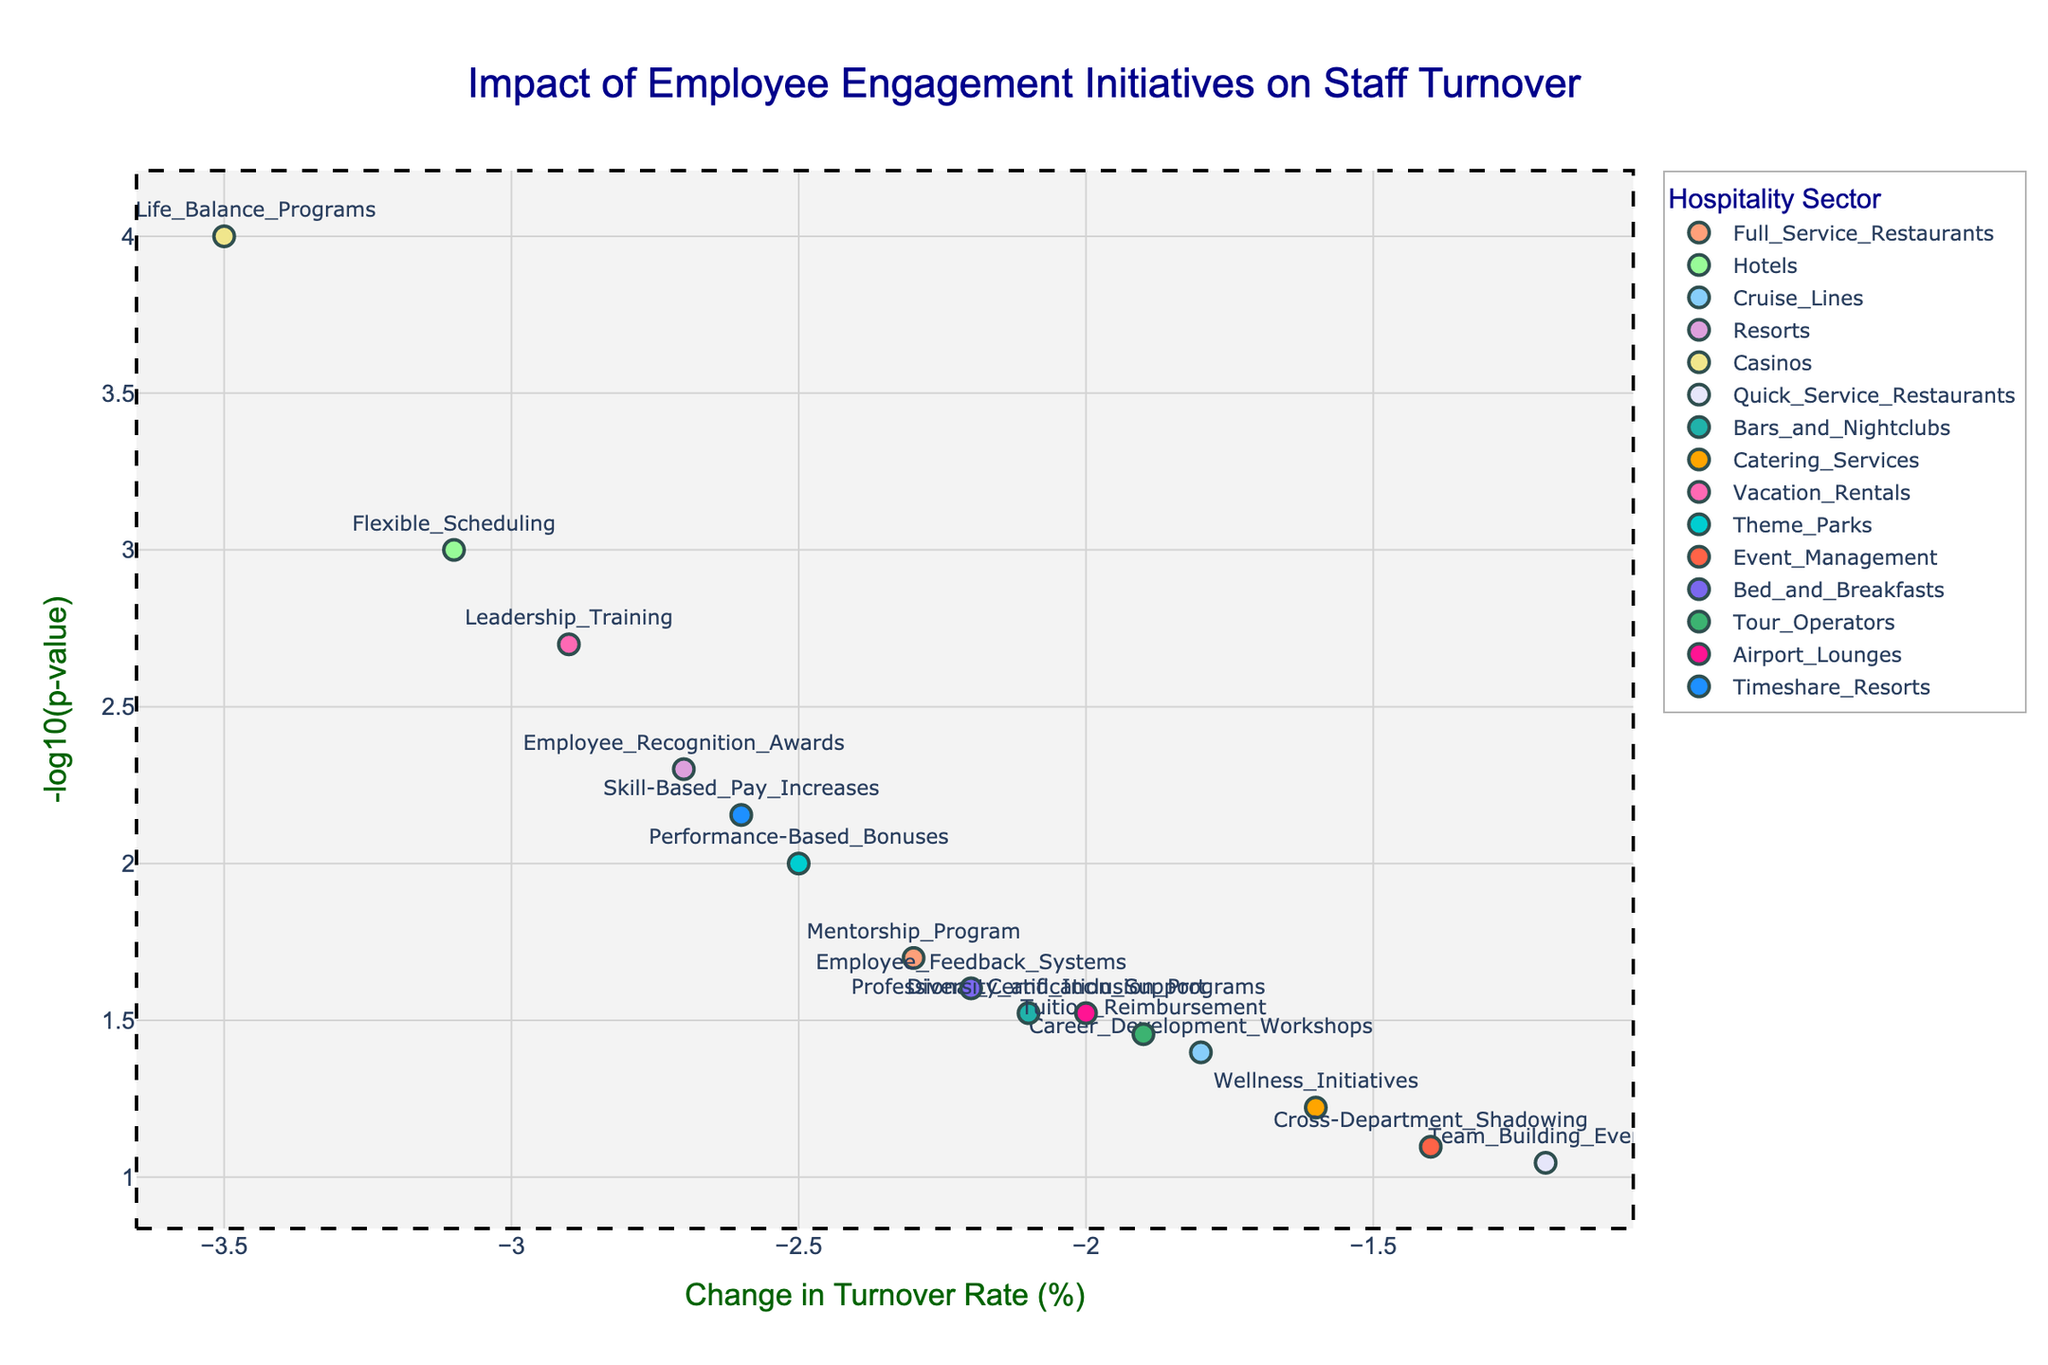How many unique hospitality sectors are represented in the plot? Identify the legend which lists all unique sectors. There are 15 different sectors mentioned: Full-Service Restaurants, Hotels, Cruise Lines, Resorts, Casinos, Quick-Service Restaurants, Bars and Nightclubs, Catering Services, Vacation Rentals, Theme Parks, Event Management, Bed and Breakfasts, Tour Operators, Airport Lounges, and Timeshare Resorts.
Answer: 15 Which staff initiative shows the largest decrease in turnover rates? Look at the points on the plot and identify the one farthest to the left on the x-axis (most negative turnover change). The initiative with the most negative turnover change is "Work-Life Balance Programs," at -3.5%.
Answer: Work-Life Balance Programs What is the significance threshold line value on the y-axis? Locate the dashed red line on the y-axis, indicating the significance threshold. The y-value where it lies is -log10(0.05), which calculates to 1.3.
Answer: 1.3 Which sector has the highest statistical significance (lowest p-value) for its staff initiative? Identify the point with the highest y-value on the plot, as higher -log10(p) correlates with lower p-value. "Work-Life Balance Programs" in Casinos has the highest y-value, with a very low p-value of 0.0001.
Answer: Casinos How many staff initiatives have a p-value below 0.01? Count the number of points above the y=axial significance threshold line (above 1.3 on the y-axis). Six initiatives cross this threshold.
Answer: 6 Which sector's staff initiative lies closest to the threshold line and what is the initiative? Identify the point closest to the y-value of 1.3. "Employee Feedback Systems” at Bed and Breakfasts is just slightly above this line.
Answer: Bed and Breakfasts, Employee Feedback Systems What is the total change in turnover rates for "Performance-Based Bonuses" and "Mentorship Program"? Sum the turnover changes. "Performance-Based Bonuses" is -2.5% and "Mentorship Program" is -2.3%. Summing these, -2.5 + (-2.3) = -4.8%.
Answer: -4.8% Which sectors have initiatives with a turnover change less than -2.5%? Determine which points lie left of -2.5 on the x-axis. Three sectors meet this criterion: Residences with "Employee Recognition Awards" (-2.7%), Theme Parks with "Performance-Based Bonuses" (-2.5%), and Casinos with "Work-Life Balance Programs" (-3.5%).
Answer: Resorts, Theme Parks, Casinos If you consider only initiatives with p-value below 0.01, which initiative has the least impact on turnover rates? Among initiatives above 1.3 on y-axis, look for least leftmost (closest to zero) x-axis value. "Skill-Based Pay Increases" in Timeshare Resorts shows a turnover change of -2.6%.
Answer: Skill-Based Pay Increases in Timeshare Resorts Which staff initiative in Vacation Rentals has a turnover change below -2% and how significant is it? Identify the point representing Vacation Rentals; from the text box, the turnover change is -2.9% with p-value of 0.002, both representing high statistical significance.
Answer: Leadership Training at Vacation Rentals, -2.9%, highly significant 